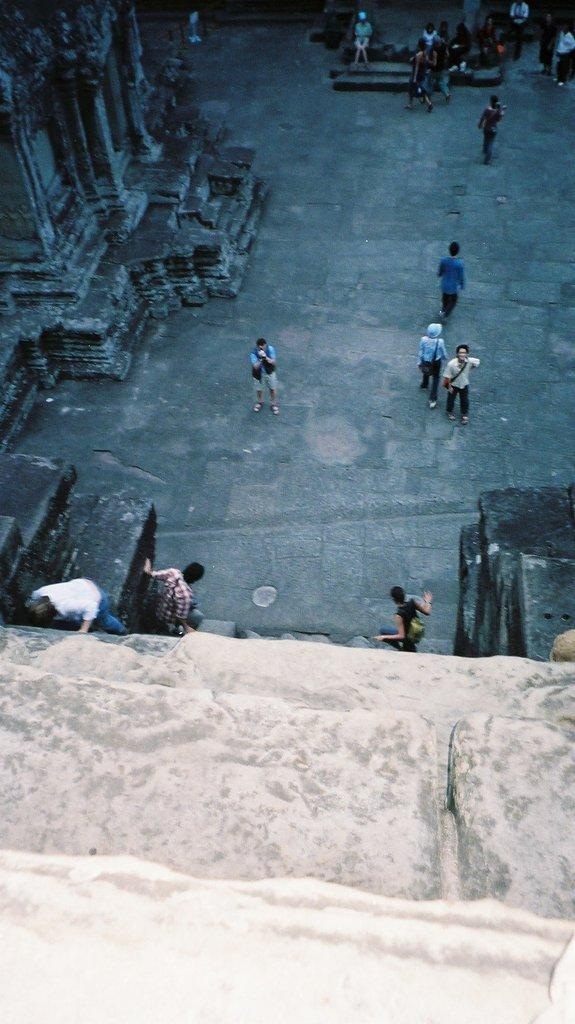What can be seen in the foreground of the image? There are stone steps in the foreground of the image. What is happening in the background of the image? There are persons walking and standing in the background of the image. What is visible on the ground in the background of the image? The ground is visible in the background of the image. What architectural feature can be seen on the left side of the image? There is a sculptured wall on the left side of the image. What organization is responsible for maintaining the rail in the image? There is no rail present in the image, so it is not possible to determine which organization might be responsible for maintaining it. 